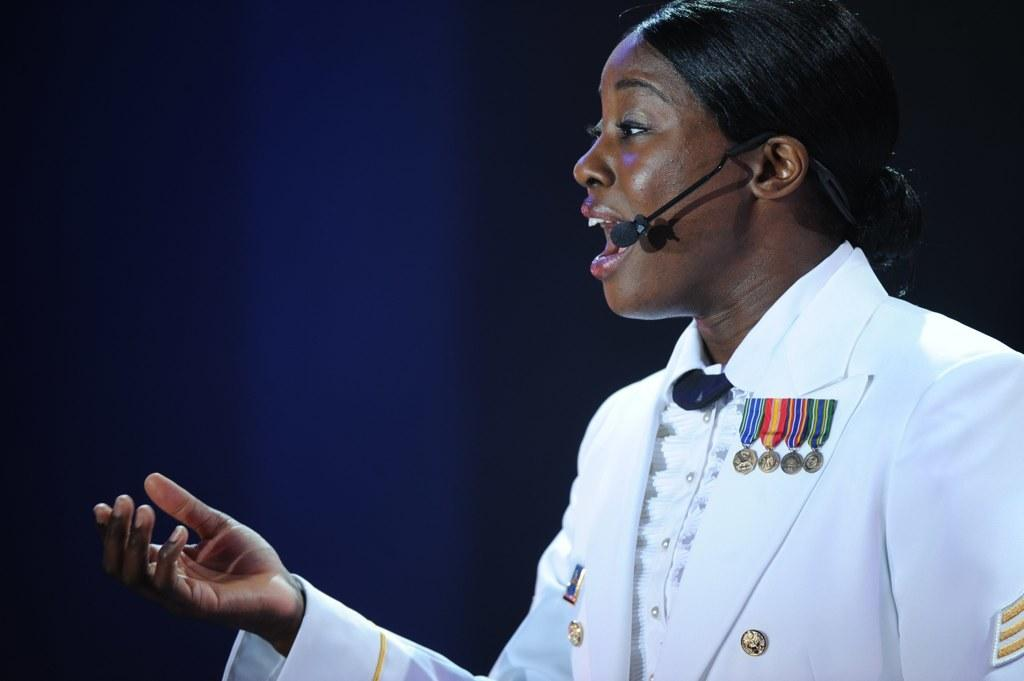Who is the main subject in the image? There is a woman in the image. What is the woman wearing? The woman is wearing a white dress. In which direction is the woman facing? The woman is facing towards the left side. What is the woman doing in the image? The woman is speaking on a microphone. What is the color of the background in the image? The background of the image is black. What type of country can be seen in the background of the image? There is no country visible in the image; the background is black. What plot is the woman discussing while speaking on the microphone? The image does not provide any information about the content of the woman's speech, so it cannot be determined what plot she might be discussing. 